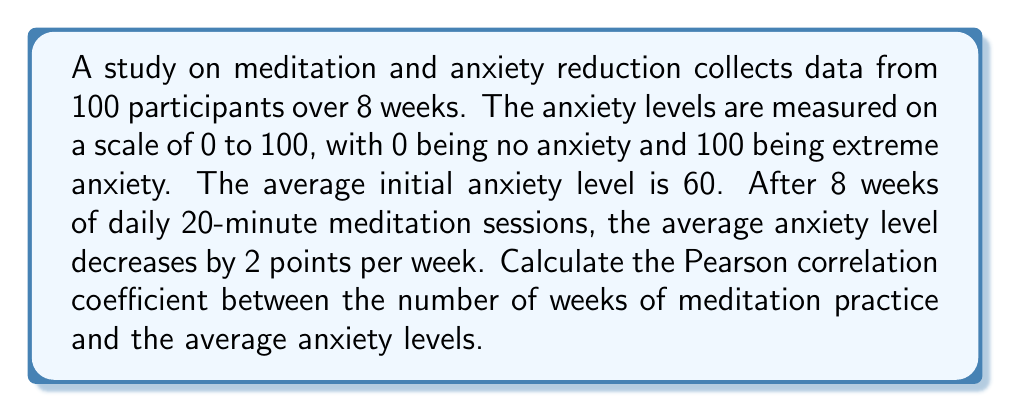Teach me how to tackle this problem. To calculate the Pearson correlation coefficient, we'll follow these steps:

1. Define variables:
   $x$: number of weeks (0 to 8)
   $y$: average anxiety level

2. Calculate mean values:
   $\bar{x} = \frac{0 + 1 + 2 + 3 + 4 + 5 + 6 + 7 + 8}{9} = 4$
   $\bar{y} = 60 - 2x$ (linear relationship)
   $\bar{y} = 60 - 2(4) = 52$

3. Calculate required sums:
   $\sum_{i=1}^{9} (x_i - \bar{x})^2 = 60$
   $\sum_{i=1}^{9} (y_i - \bar{y})^2 = 240$
   $\sum_{i=1}^{9} (x_i - \bar{x})(y_i - \bar{y}) = -120$

4. Apply the Pearson correlation coefficient formula:
   $$r = \frac{\sum_{i=1}^{9} (x_i - \bar{x})(y_i - \bar{y})}{\sqrt{\sum_{i=1}^{9} (x_i - \bar{x})^2 \sum_{i=1}^{9} (y_i - \bar{y})^2}}$$

   $$r = \frac{-120}{\sqrt{60 \cdot 240}} = \frac{-120}{\sqrt{14400}} = \frac{-120}{120} = -1$$

The correlation coefficient of -1 indicates a perfect negative linear relationship between meditation practice duration and anxiety levels.
Answer: $-1$ 